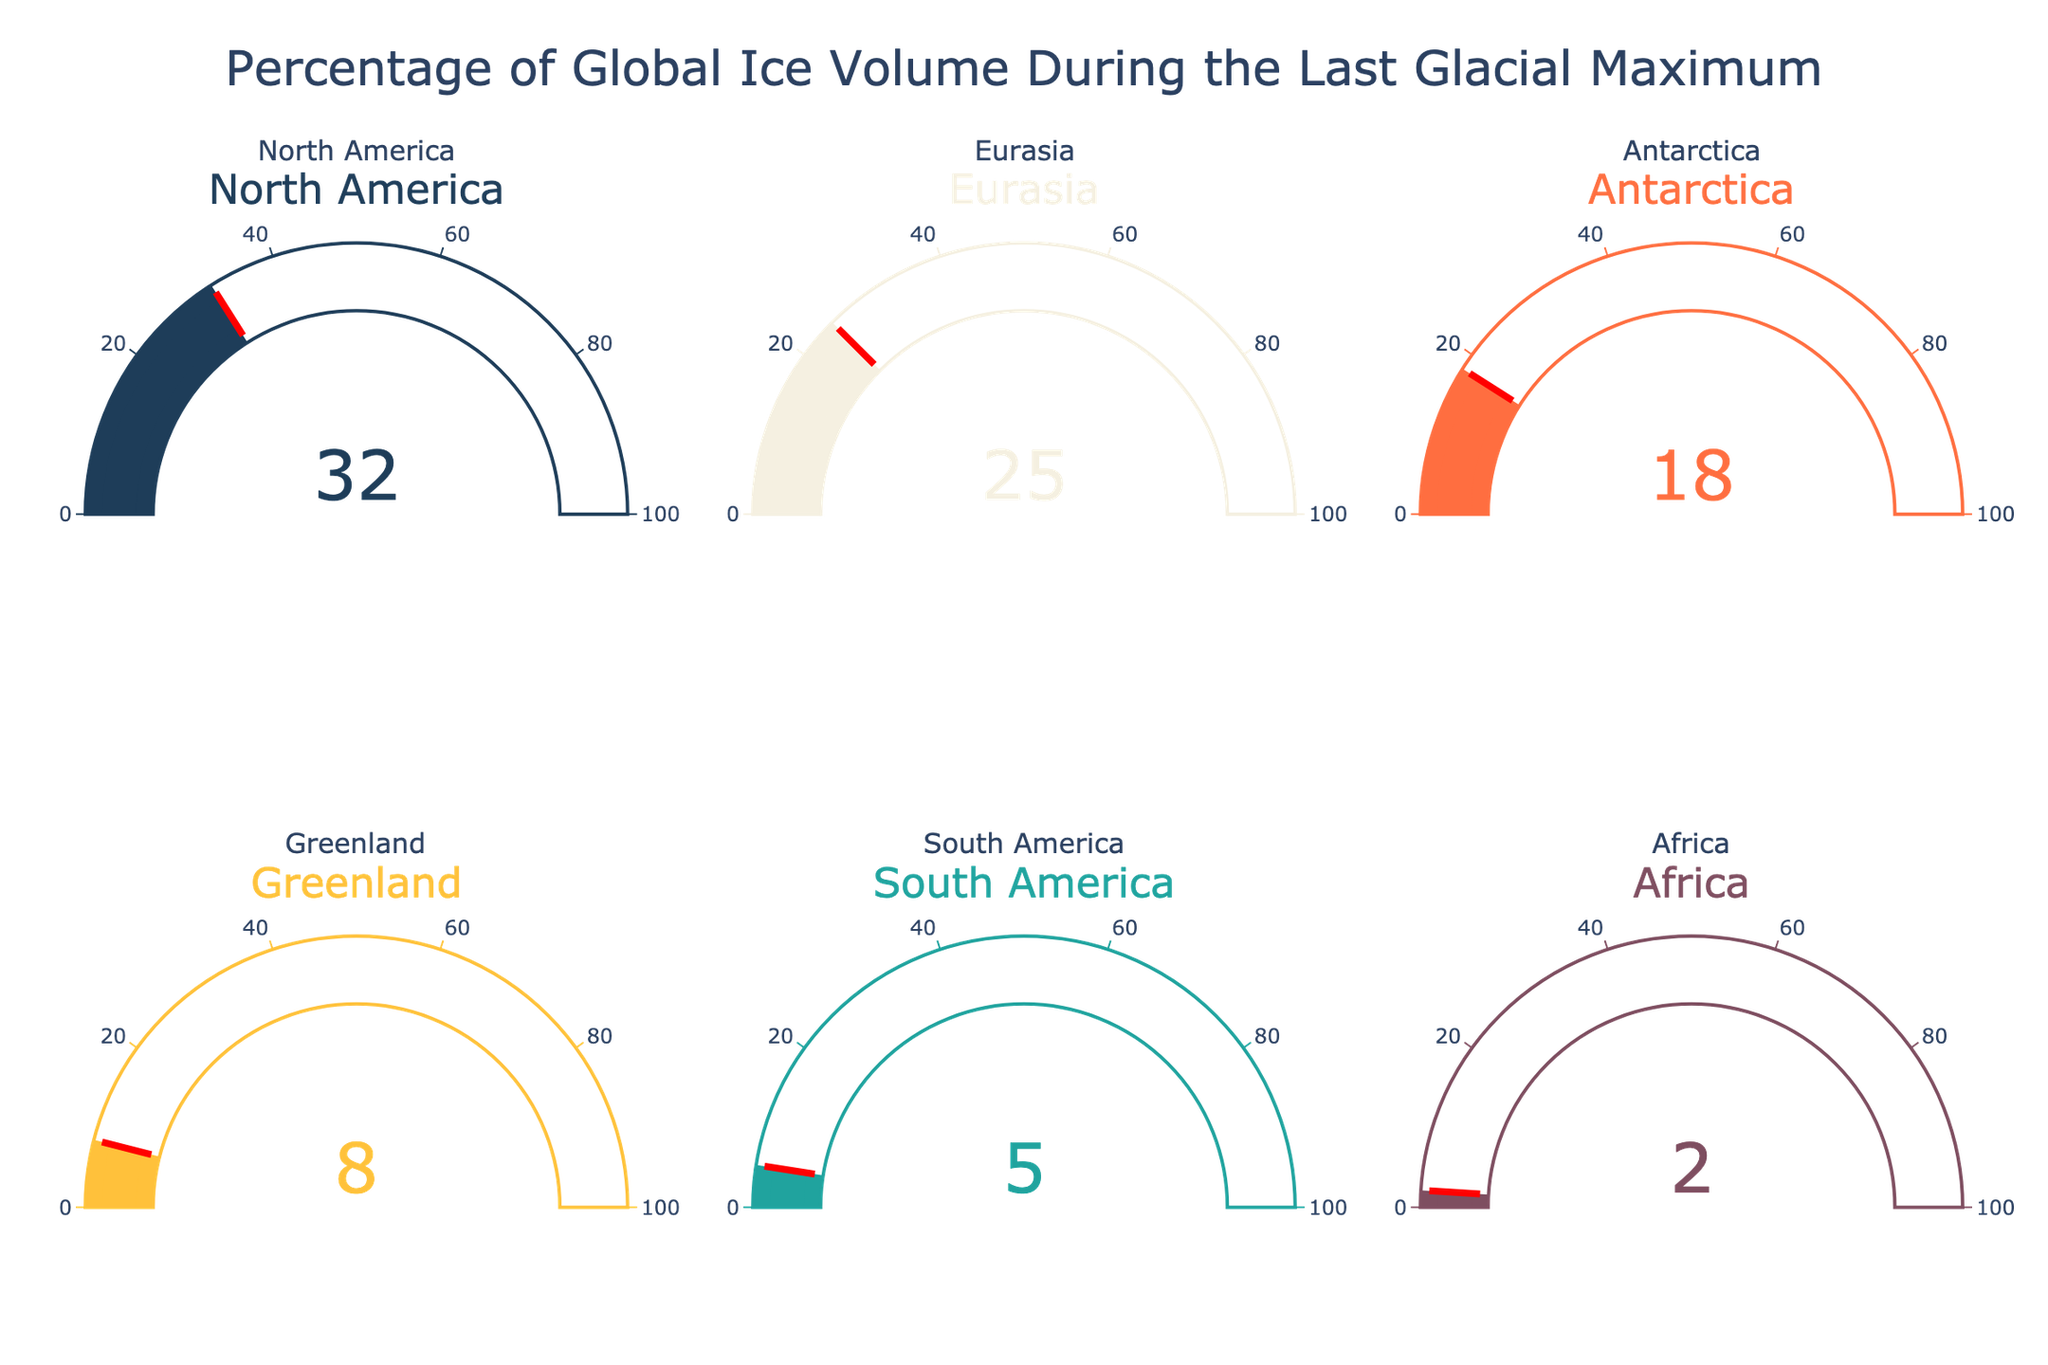what's the title of the figure? The title is usually positioned at the top of the figure. In this case, it states "Percentage of Global Ice Volume During the Last Glacial Maximum".
Answer: "Percentage of Global Ice Volume During the Last Glacial Maximum" how many regions are represented in the figure? The figure includes six gauges, each representing a different region. You can confirm by counting the gauges or reading the subplot titles.
Answer: 6 what is the ice volume percentage of North America? The value is displayed within the gauge for North America.
Answer: 32% which region has the smallest ice volume percentage? By comparing all the displayed values, Africa has the smallest gauge reading.
Answer: Africa which region has the highest ice volume percentage? By comparing all the displayed values, North America has the highest gauge reading.
Answer: North America what is the combined ice volume percentage of Eurasia and Antarctica? Add the values for Eurasia (25%) and Antarctica (18%). So, 25 + 18 = 43.
Answer: 43% what is the average ice volume percentage across all regions? Sum all the percentages: 32 + 25 + 18 + 8 + 5 + 2 = 90, then divide by the number of regions, 90 / 6 = 15.
Answer: 15% is the ice volume percentage of Greenland greater than that of South America? Compare the values of Greenland (8%) and South America (5%). Since 8 is greater than 5, Greenland has a higher percentage.
Answer: Yes how much higher is North America's ice volume percentage compared to Africa's? Subtract Africa's percentage (2%) from North America's percentage (32%). So, 32 - 2 = 30.
Answer: 30% 